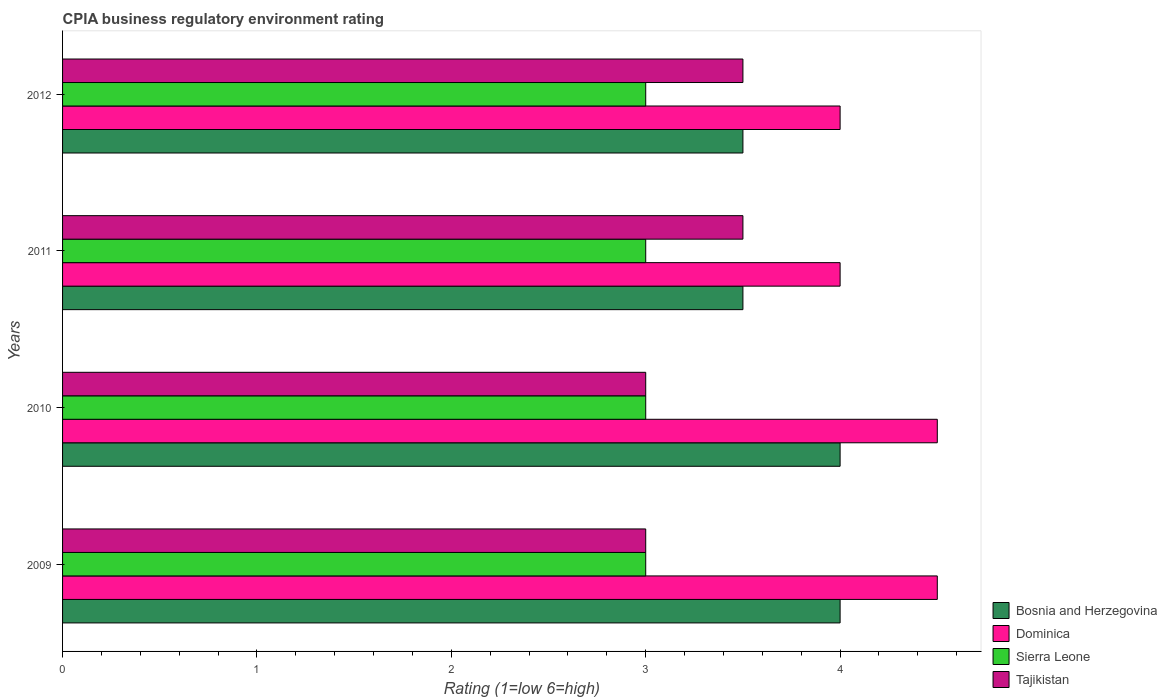How many different coloured bars are there?
Provide a short and direct response. 4. How many groups of bars are there?
Ensure brevity in your answer.  4. How many bars are there on the 1st tick from the bottom?
Keep it short and to the point. 4. What is the label of the 4th group of bars from the top?
Provide a short and direct response. 2009. What is the CPIA rating in Sierra Leone in 2011?
Give a very brief answer. 3. Across all years, what is the maximum CPIA rating in Bosnia and Herzegovina?
Provide a succinct answer. 4. In which year was the CPIA rating in Tajikistan maximum?
Keep it short and to the point. 2011. In which year was the CPIA rating in Dominica minimum?
Offer a terse response. 2011. What is the total CPIA rating in Sierra Leone in the graph?
Provide a succinct answer. 12. What is the average CPIA rating in Sierra Leone per year?
Offer a terse response. 3. In the year 2009, what is the difference between the CPIA rating in Bosnia and Herzegovina and CPIA rating in Tajikistan?
Give a very brief answer. 1. In how many years, is the CPIA rating in Tajikistan greater than 1.8 ?
Offer a very short reply. 4. Is the CPIA rating in Sierra Leone in 2009 less than that in 2011?
Give a very brief answer. No. Is the difference between the CPIA rating in Bosnia and Herzegovina in 2009 and 2011 greater than the difference between the CPIA rating in Tajikistan in 2009 and 2011?
Make the answer very short. Yes. What is the difference between the highest and the lowest CPIA rating in Tajikistan?
Offer a terse response. 0.5. Is the sum of the CPIA rating in Sierra Leone in 2010 and 2012 greater than the maximum CPIA rating in Bosnia and Herzegovina across all years?
Provide a succinct answer. Yes. What does the 3rd bar from the top in 2010 represents?
Make the answer very short. Dominica. What does the 3rd bar from the bottom in 2010 represents?
Make the answer very short. Sierra Leone. Are all the bars in the graph horizontal?
Make the answer very short. Yes. How many years are there in the graph?
Offer a very short reply. 4. What is the difference between two consecutive major ticks on the X-axis?
Provide a short and direct response. 1. Does the graph contain any zero values?
Offer a very short reply. No. Where does the legend appear in the graph?
Give a very brief answer. Bottom right. How many legend labels are there?
Provide a short and direct response. 4. What is the title of the graph?
Give a very brief answer. CPIA business regulatory environment rating. What is the Rating (1=low 6=high) in Dominica in 2009?
Offer a very short reply. 4.5. What is the Rating (1=low 6=high) in Sierra Leone in 2009?
Ensure brevity in your answer.  3. What is the Rating (1=low 6=high) in Dominica in 2010?
Offer a very short reply. 4.5. What is the Rating (1=low 6=high) of Tajikistan in 2010?
Provide a short and direct response. 3. What is the Rating (1=low 6=high) of Sierra Leone in 2011?
Provide a short and direct response. 3. What is the Rating (1=low 6=high) of Bosnia and Herzegovina in 2012?
Your response must be concise. 3.5. Across all years, what is the maximum Rating (1=low 6=high) of Dominica?
Provide a short and direct response. 4.5. Across all years, what is the maximum Rating (1=low 6=high) in Tajikistan?
Your answer should be very brief. 3.5. Across all years, what is the minimum Rating (1=low 6=high) of Bosnia and Herzegovina?
Keep it short and to the point. 3.5. Across all years, what is the minimum Rating (1=low 6=high) in Sierra Leone?
Your response must be concise. 3. Across all years, what is the minimum Rating (1=low 6=high) in Tajikistan?
Give a very brief answer. 3. What is the total Rating (1=low 6=high) of Bosnia and Herzegovina in the graph?
Give a very brief answer. 15. What is the total Rating (1=low 6=high) of Dominica in the graph?
Give a very brief answer. 17. What is the total Rating (1=low 6=high) of Sierra Leone in the graph?
Offer a terse response. 12. What is the difference between the Rating (1=low 6=high) in Bosnia and Herzegovina in 2009 and that in 2010?
Provide a succinct answer. 0. What is the difference between the Rating (1=low 6=high) in Sierra Leone in 2009 and that in 2010?
Offer a terse response. 0. What is the difference between the Rating (1=low 6=high) in Tajikistan in 2009 and that in 2010?
Provide a short and direct response. 0. What is the difference between the Rating (1=low 6=high) of Bosnia and Herzegovina in 2009 and that in 2011?
Provide a short and direct response. 0.5. What is the difference between the Rating (1=low 6=high) of Dominica in 2009 and that in 2011?
Provide a short and direct response. 0.5. What is the difference between the Rating (1=low 6=high) of Tajikistan in 2009 and that in 2011?
Keep it short and to the point. -0.5. What is the difference between the Rating (1=low 6=high) in Dominica in 2009 and that in 2012?
Give a very brief answer. 0.5. What is the difference between the Rating (1=low 6=high) of Sierra Leone in 2009 and that in 2012?
Make the answer very short. 0. What is the difference between the Rating (1=low 6=high) of Tajikistan in 2009 and that in 2012?
Make the answer very short. -0.5. What is the difference between the Rating (1=low 6=high) of Bosnia and Herzegovina in 2010 and that in 2011?
Offer a terse response. 0.5. What is the difference between the Rating (1=low 6=high) of Dominica in 2010 and that in 2011?
Ensure brevity in your answer.  0.5. What is the difference between the Rating (1=low 6=high) of Sierra Leone in 2010 and that in 2011?
Offer a very short reply. 0. What is the difference between the Rating (1=low 6=high) in Tajikistan in 2010 and that in 2011?
Keep it short and to the point. -0.5. What is the difference between the Rating (1=low 6=high) in Dominica in 2010 and that in 2012?
Your answer should be compact. 0.5. What is the difference between the Rating (1=low 6=high) in Tajikistan in 2010 and that in 2012?
Make the answer very short. -0.5. What is the difference between the Rating (1=low 6=high) in Dominica in 2011 and that in 2012?
Your answer should be compact. 0. What is the difference between the Rating (1=low 6=high) in Tajikistan in 2011 and that in 2012?
Offer a very short reply. 0. What is the difference between the Rating (1=low 6=high) in Bosnia and Herzegovina in 2009 and the Rating (1=low 6=high) in Dominica in 2010?
Offer a terse response. -0.5. What is the difference between the Rating (1=low 6=high) in Bosnia and Herzegovina in 2009 and the Rating (1=low 6=high) in Tajikistan in 2010?
Offer a terse response. 1. What is the difference between the Rating (1=low 6=high) of Dominica in 2009 and the Rating (1=low 6=high) of Sierra Leone in 2010?
Your answer should be compact. 1.5. What is the difference between the Rating (1=low 6=high) in Dominica in 2009 and the Rating (1=low 6=high) in Tajikistan in 2010?
Your response must be concise. 1.5. What is the difference between the Rating (1=low 6=high) in Sierra Leone in 2009 and the Rating (1=low 6=high) in Tajikistan in 2010?
Your response must be concise. 0. What is the difference between the Rating (1=low 6=high) in Bosnia and Herzegovina in 2009 and the Rating (1=low 6=high) in Dominica in 2011?
Provide a short and direct response. 0. What is the difference between the Rating (1=low 6=high) in Dominica in 2009 and the Rating (1=low 6=high) in Tajikistan in 2011?
Ensure brevity in your answer.  1. What is the difference between the Rating (1=low 6=high) of Bosnia and Herzegovina in 2009 and the Rating (1=low 6=high) of Sierra Leone in 2012?
Make the answer very short. 1. What is the difference between the Rating (1=low 6=high) in Bosnia and Herzegovina in 2009 and the Rating (1=low 6=high) in Tajikistan in 2012?
Offer a very short reply. 0.5. What is the difference between the Rating (1=low 6=high) in Dominica in 2009 and the Rating (1=low 6=high) in Sierra Leone in 2012?
Give a very brief answer. 1.5. What is the difference between the Rating (1=low 6=high) of Sierra Leone in 2009 and the Rating (1=low 6=high) of Tajikistan in 2012?
Your answer should be very brief. -0.5. What is the difference between the Rating (1=low 6=high) of Bosnia and Herzegovina in 2010 and the Rating (1=low 6=high) of Sierra Leone in 2011?
Offer a very short reply. 1. What is the difference between the Rating (1=low 6=high) of Dominica in 2010 and the Rating (1=low 6=high) of Tajikistan in 2011?
Your answer should be compact. 1. What is the difference between the Rating (1=low 6=high) of Sierra Leone in 2010 and the Rating (1=low 6=high) of Tajikistan in 2011?
Give a very brief answer. -0.5. What is the difference between the Rating (1=low 6=high) of Sierra Leone in 2010 and the Rating (1=low 6=high) of Tajikistan in 2012?
Make the answer very short. -0.5. What is the difference between the Rating (1=low 6=high) in Bosnia and Herzegovina in 2011 and the Rating (1=low 6=high) in Dominica in 2012?
Give a very brief answer. -0.5. What is the difference between the Rating (1=low 6=high) in Bosnia and Herzegovina in 2011 and the Rating (1=low 6=high) in Tajikistan in 2012?
Make the answer very short. 0. What is the average Rating (1=low 6=high) of Bosnia and Herzegovina per year?
Your answer should be compact. 3.75. What is the average Rating (1=low 6=high) in Dominica per year?
Your answer should be compact. 4.25. In the year 2009, what is the difference between the Rating (1=low 6=high) in Bosnia and Herzegovina and Rating (1=low 6=high) in Sierra Leone?
Offer a terse response. 1. In the year 2009, what is the difference between the Rating (1=low 6=high) in Dominica and Rating (1=low 6=high) in Sierra Leone?
Offer a very short reply. 1.5. In the year 2009, what is the difference between the Rating (1=low 6=high) in Dominica and Rating (1=low 6=high) in Tajikistan?
Provide a short and direct response. 1.5. In the year 2009, what is the difference between the Rating (1=low 6=high) of Sierra Leone and Rating (1=low 6=high) of Tajikistan?
Offer a very short reply. 0. In the year 2010, what is the difference between the Rating (1=low 6=high) in Bosnia and Herzegovina and Rating (1=low 6=high) in Sierra Leone?
Keep it short and to the point. 1. In the year 2010, what is the difference between the Rating (1=low 6=high) of Dominica and Rating (1=low 6=high) of Sierra Leone?
Offer a very short reply. 1.5. In the year 2010, what is the difference between the Rating (1=low 6=high) in Dominica and Rating (1=low 6=high) in Tajikistan?
Offer a very short reply. 1.5. In the year 2011, what is the difference between the Rating (1=low 6=high) in Bosnia and Herzegovina and Rating (1=low 6=high) in Dominica?
Your response must be concise. -0.5. In the year 2011, what is the difference between the Rating (1=low 6=high) of Sierra Leone and Rating (1=low 6=high) of Tajikistan?
Keep it short and to the point. -0.5. In the year 2012, what is the difference between the Rating (1=low 6=high) in Dominica and Rating (1=low 6=high) in Tajikistan?
Your response must be concise. 0.5. In the year 2012, what is the difference between the Rating (1=low 6=high) of Sierra Leone and Rating (1=low 6=high) of Tajikistan?
Make the answer very short. -0.5. What is the ratio of the Rating (1=low 6=high) in Bosnia and Herzegovina in 2009 to that in 2010?
Your answer should be very brief. 1. What is the ratio of the Rating (1=low 6=high) in Dominica in 2009 to that in 2010?
Offer a terse response. 1. What is the ratio of the Rating (1=low 6=high) of Tajikistan in 2009 to that in 2010?
Make the answer very short. 1. What is the ratio of the Rating (1=low 6=high) of Bosnia and Herzegovina in 2009 to that in 2011?
Ensure brevity in your answer.  1.14. What is the ratio of the Rating (1=low 6=high) of Dominica in 2009 to that in 2011?
Offer a very short reply. 1.12. What is the ratio of the Rating (1=low 6=high) of Sierra Leone in 2009 to that in 2011?
Your answer should be compact. 1. What is the ratio of the Rating (1=low 6=high) in Dominica in 2009 to that in 2012?
Offer a terse response. 1.12. What is the ratio of the Rating (1=low 6=high) in Sierra Leone in 2009 to that in 2012?
Your answer should be compact. 1. What is the ratio of the Rating (1=low 6=high) in Tajikistan in 2009 to that in 2012?
Your answer should be compact. 0.86. What is the ratio of the Rating (1=low 6=high) in Bosnia and Herzegovina in 2010 to that in 2012?
Provide a short and direct response. 1.14. What is the ratio of the Rating (1=low 6=high) in Dominica in 2010 to that in 2012?
Offer a very short reply. 1.12. What is the ratio of the Rating (1=low 6=high) of Sierra Leone in 2010 to that in 2012?
Your answer should be very brief. 1. What is the ratio of the Rating (1=low 6=high) of Tajikistan in 2010 to that in 2012?
Provide a succinct answer. 0.86. What is the ratio of the Rating (1=low 6=high) in Bosnia and Herzegovina in 2011 to that in 2012?
Your answer should be very brief. 1. What is the ratio of the Rating (1=low 6=high) of Dominica in 2011 to that in 2012?
Your answer should be compact. 1. What is the difference between the highest and the second highest Rating (1=low 6=high) in Bosnia and Herzegovina?
Give a very brief answer. 0. What is the difference between the highest and the lowest Rating (1=low 6=high) of Bosnia and Herzegovina?
Give a very brief answer. 0.5. What is the difference between the highest and the lowest Rating (1=low 6=high) of Sierra Leone?
Provide a succinct answer. 0. 